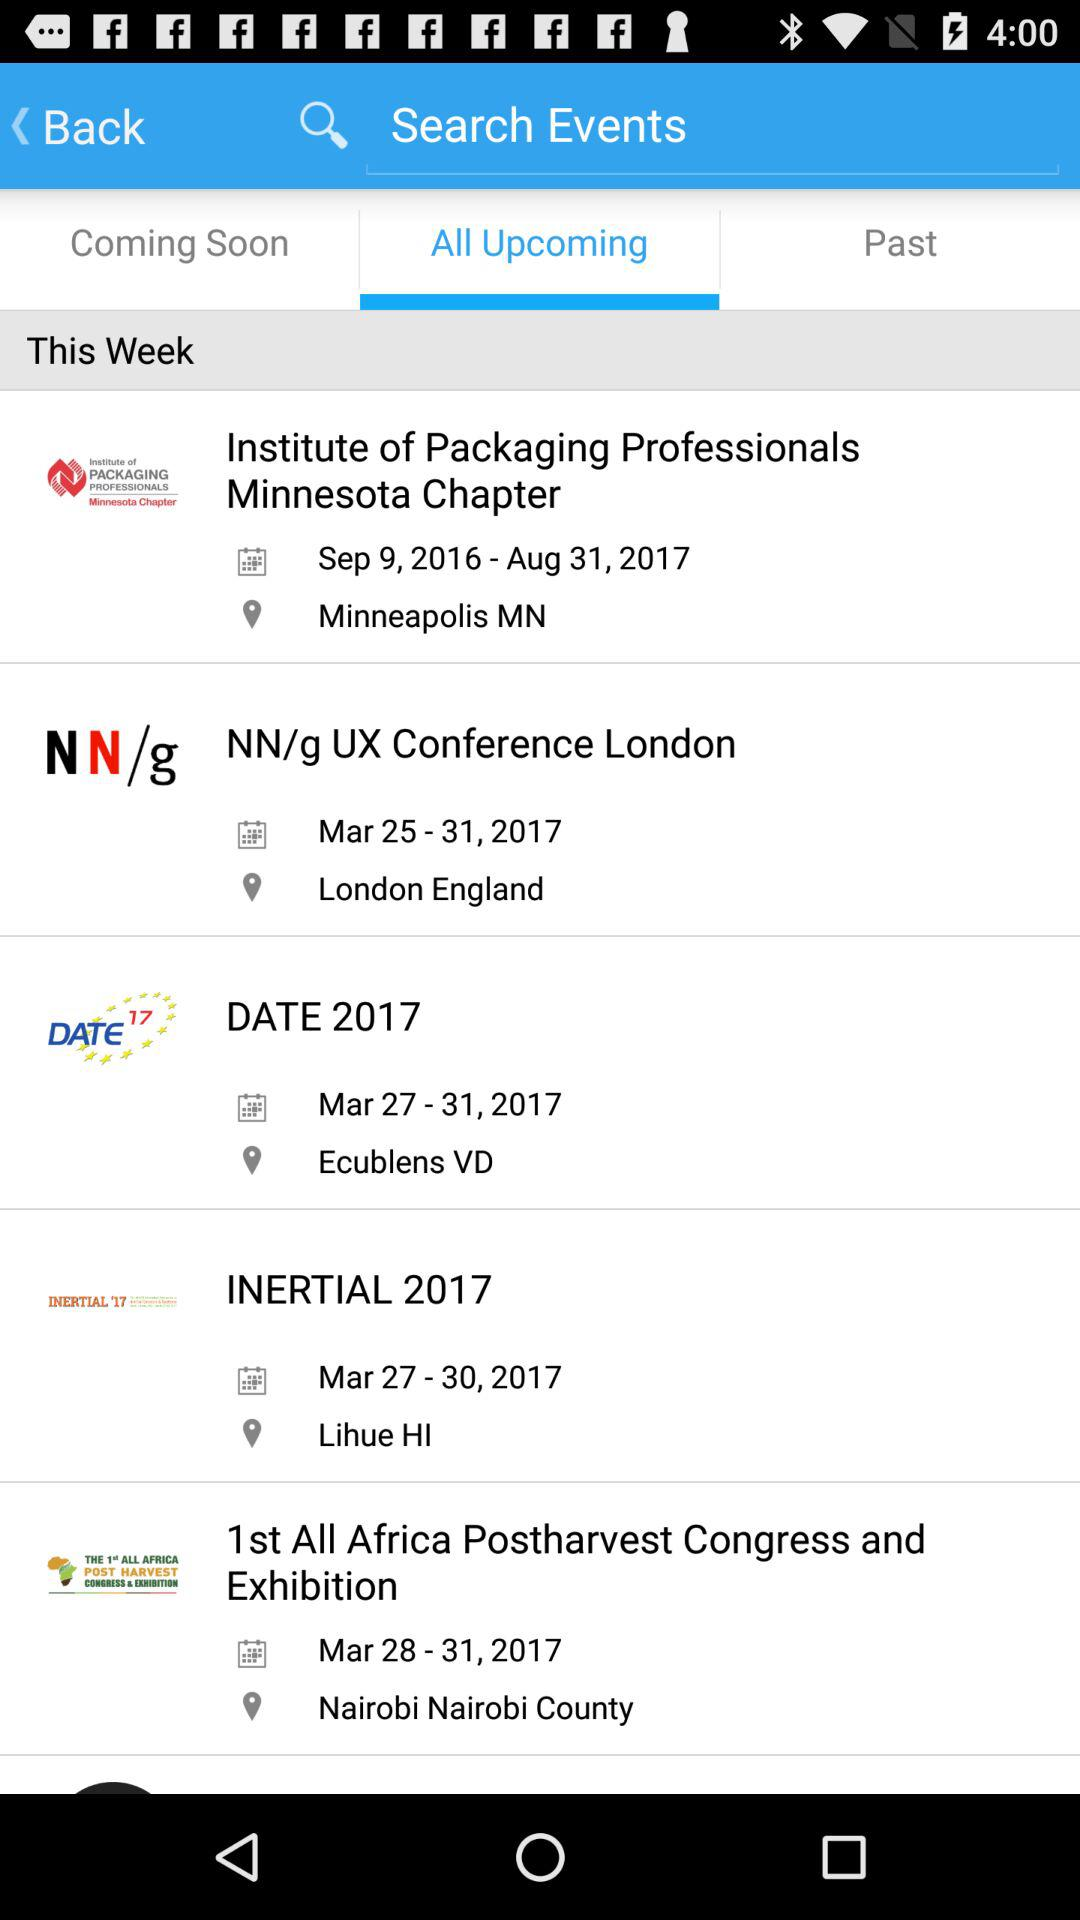What is the location of "INERTIAL 2017"? The location of "INERTIAL 2017" is Lihue, Hawaii. 